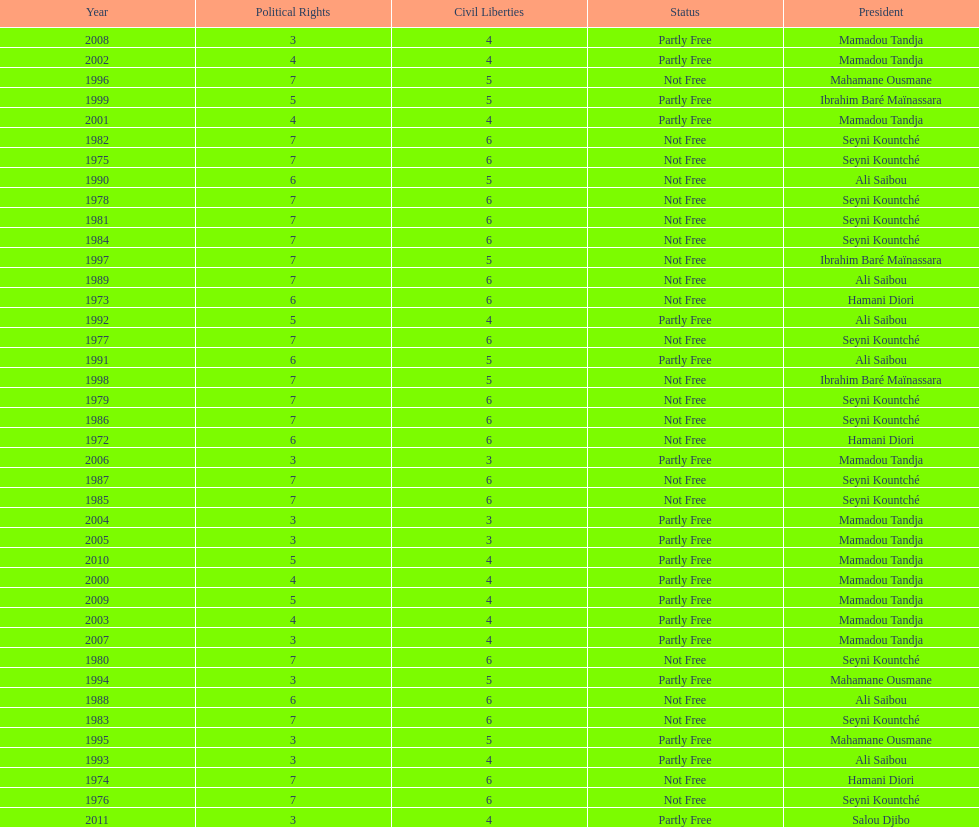Who was president before mamadou tandja? Ibrahim Baré Maïnassara. Would you be able to parse every entry in this table? {'header': ['Year', 'Political Rights', 'Civil Liberties', 'Status', 'President'], 'rows': [['2008', '3', '4', 'Partly Free', 'Mamadou Tandja'], ['2002', '4', '4', 'Partly Free', 'Mamadou Tandja'], ['1996', '7', '5', 'Not Free', 'Mahamane Ousmane'], ['1999', '5', '5', 'Partly Free', 'Ibrahim Baré Maïnassara'], ['2001', '4', '4', 'Partly Free', 'Mamadou Tandja'], ['1982', '7', '6', 'Not Free', 'Seyni Kountché'], ['1975', '7', '6', 'Not Free', 'Seyni Kountché'], ['1990', '6', '5', 'Not Free', 'Ali Saibou'], ['1978', '7', '6', 'Not Free', 'Seyni Kountché'], ['1981', '7', '6', 'Not Free', 'Seyni Kountché'], ['1984', '7', '6', 'Not Free', 'Seyni Kountché'], ['1997', '7', '5', 'Not Free', 'Ibrahim Baré Maïnassara'], ['1989', '7', '6', 'Not Free', 'Ali Saibou'], ['1973', '6', '6', 'Not Free', 'Hamani Diori'], ['1992', '5', '4', 'Partly Free', 'Ali Saibou'], ['1977', '7', '6', 'Not Free', 'Seyni Kountché'], ['1991', '6', '5', 'Partly Free', 'Ali Saibou'], ['1998', '7', '5', 'Not Free', 'Ibrahim Baré Maïnassara'], ['1979', '7', '6', 'Not Free', 'Seyni Kountché'], ['1986', '7', '6', 'Not Free', 'Seyni Kountché'], ['1972', '6', '6', 'Not Free', 'Hamani Diori'], ['2006', '3', '3', 'Partly Free', 'Mamadou Tandja'], ['1987', '7', '6', 'Not Free', 'Seyni Kountché'], ['1985', '7', '6', 'Not Free', 'Seyni Kountché'], ['2004', '3', '3', 'Partly Free', 'Mamadou Tandja'], ['2005', '3', '3', 'Partly Free', 'Mamadou Tandja'], ['2010', '5', '4', 'Partly Free', 'Mamadou Tandja'], ['2000', '4', '4', 'Partly Free', 'Mamadou Tandja'], ['2009', '5', '4', 'Partly Free', 'Mamadou Tandja'], ['2003', '4', '4', 'Partly Free', 'Mamadou Tandja'], ['2007', '3', '4', 'Partly Free', 'Mamadou Tandja'], ['1980', '7', '6', 'Not Free', 'Seyni Kountché'], ['1994', '3', '5', 'Partly Free', 'Mahamane Ousmane'], ['1988', '6', '6', 'Not Free', 'Ali Saibou'], ['1983', '7', '6', 'Not Free', 'Seyni Kountché'], ['1995', '3', '5', 'Partly Free', 'Mahamane Ousmane'], ['1993', '3', '4', 'Partly Free', 'Ali Saibou'], ['1974', '7', '6', 'Not Free', 'Hamani Diori'], ['1976', '7', '6', 'Not Free', 'Seyni Kountché'], ['2011', '3', '4', 'Partly Free', 'Salou Djibo']]} 